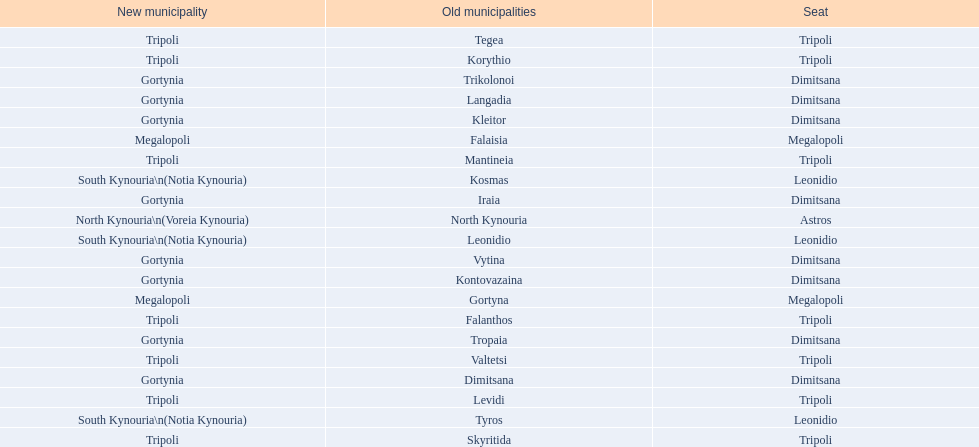Is tripoli still considered a municipality in arcadia since its 2011 reformation? Yes. 